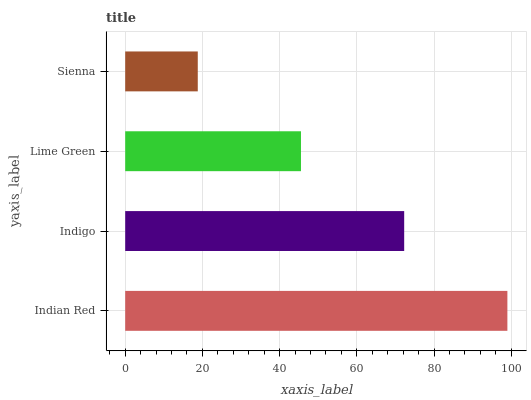Is Sienna the minimum?
Answer yes or no. Yes. Is Indian Red the maximum?
Answer yes or no. Yes. Is Indigo the minimum?
Answer yes or no. No. Is Indigo the maximum?
Answer yes or no. No. Is Indian Red greater than Indigo?
Answer yes or no. Yes. Is Indigo less than Indian Red?
Answer yes or no. Yes. Is Indigo greater than Indian Red?
Answer yes or no. No. Is Indian Red less than Indigo?
Answer yes or no. No. Is Indigo the high median?
Answer yes or no. Yes. Is Lime Green the low median?
Answer yes or no. Yes. Is Lime Green the high median?
Answer yes or no. No. Is Sienna the low median?
Answer yes or no. No. 